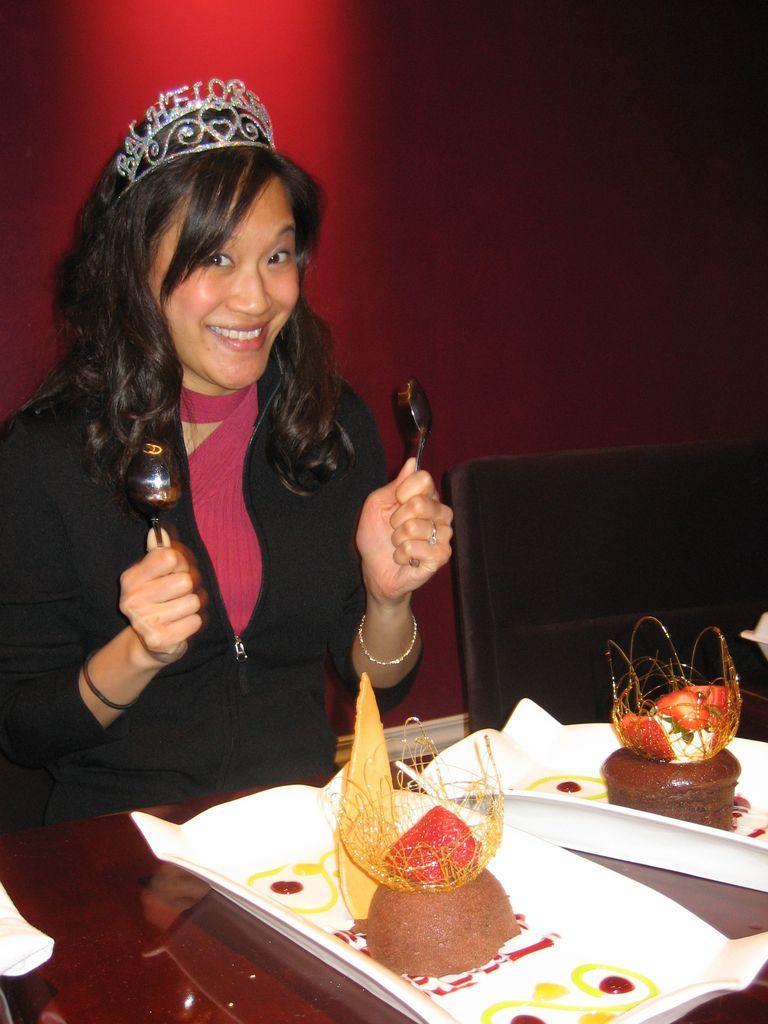Can you describe this image briefly? In this image, we can see a person wearing clothes and holding spoons with her hands. There is a chair on the right side of the image. There is a table at the bottom of the image contains plates with objects. 